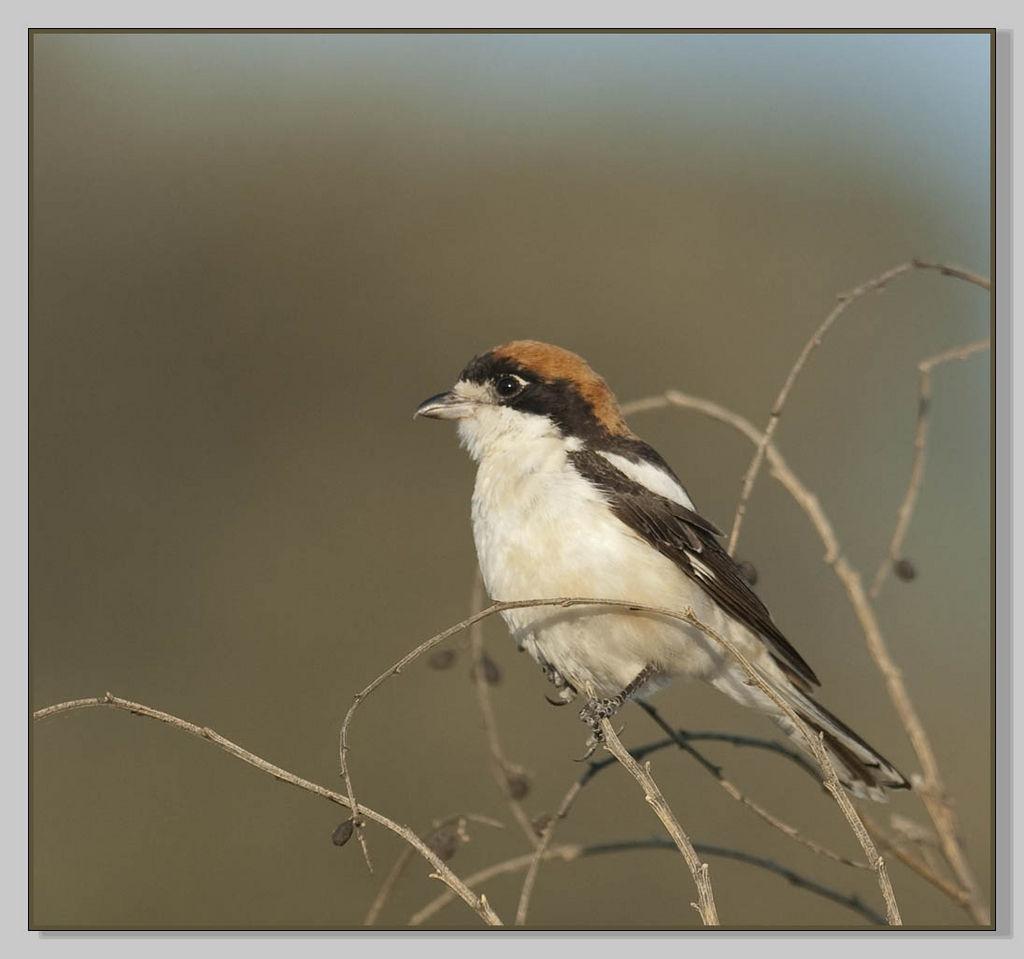Please provide a concise description of this image. In this image I can see few stems and a bird. I can see colour of this bird is white, black and brown. I can also see this image is blurry from background. 